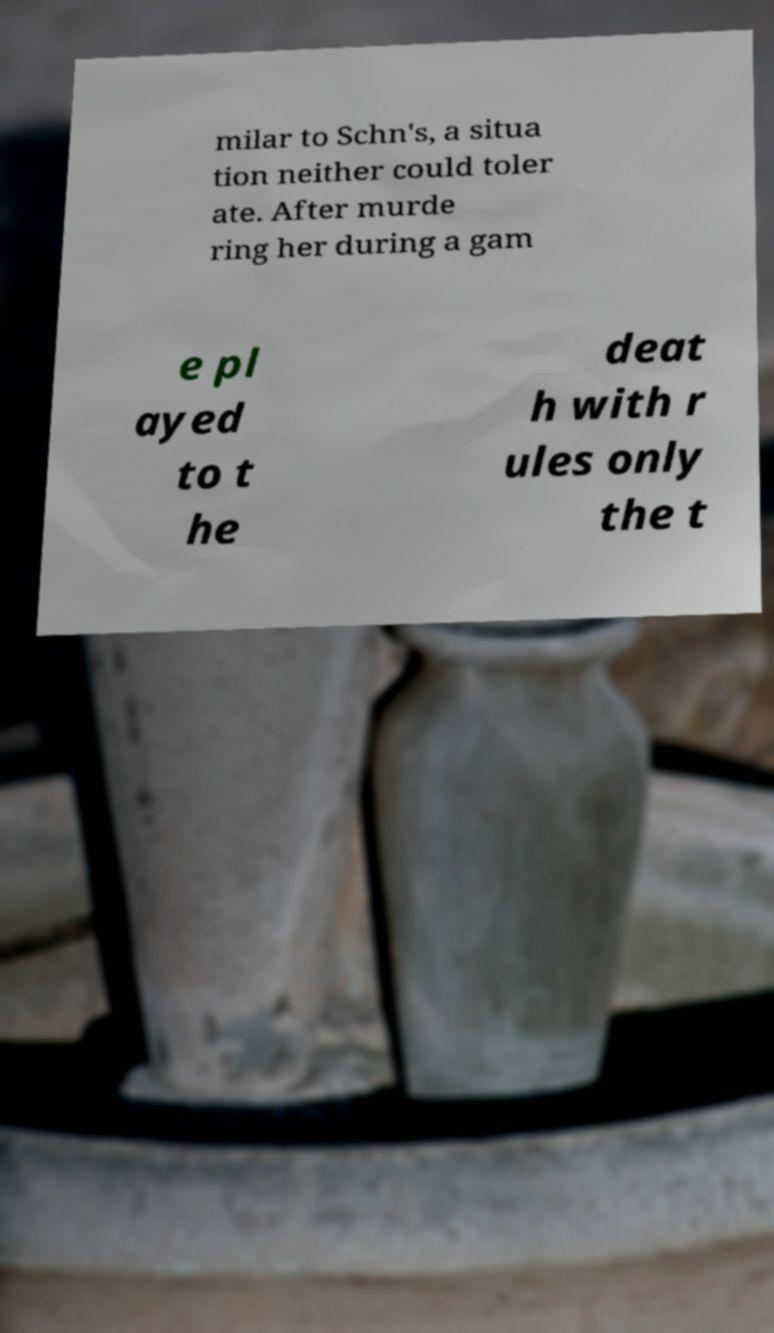There's text embedded in this image that I need extracted. Can you transcribe it verbatim? milar to Schn's, a situa tion neither could toler ate. After murde ring her during a gam e pl ayed to t he deat h with r ules only the t 